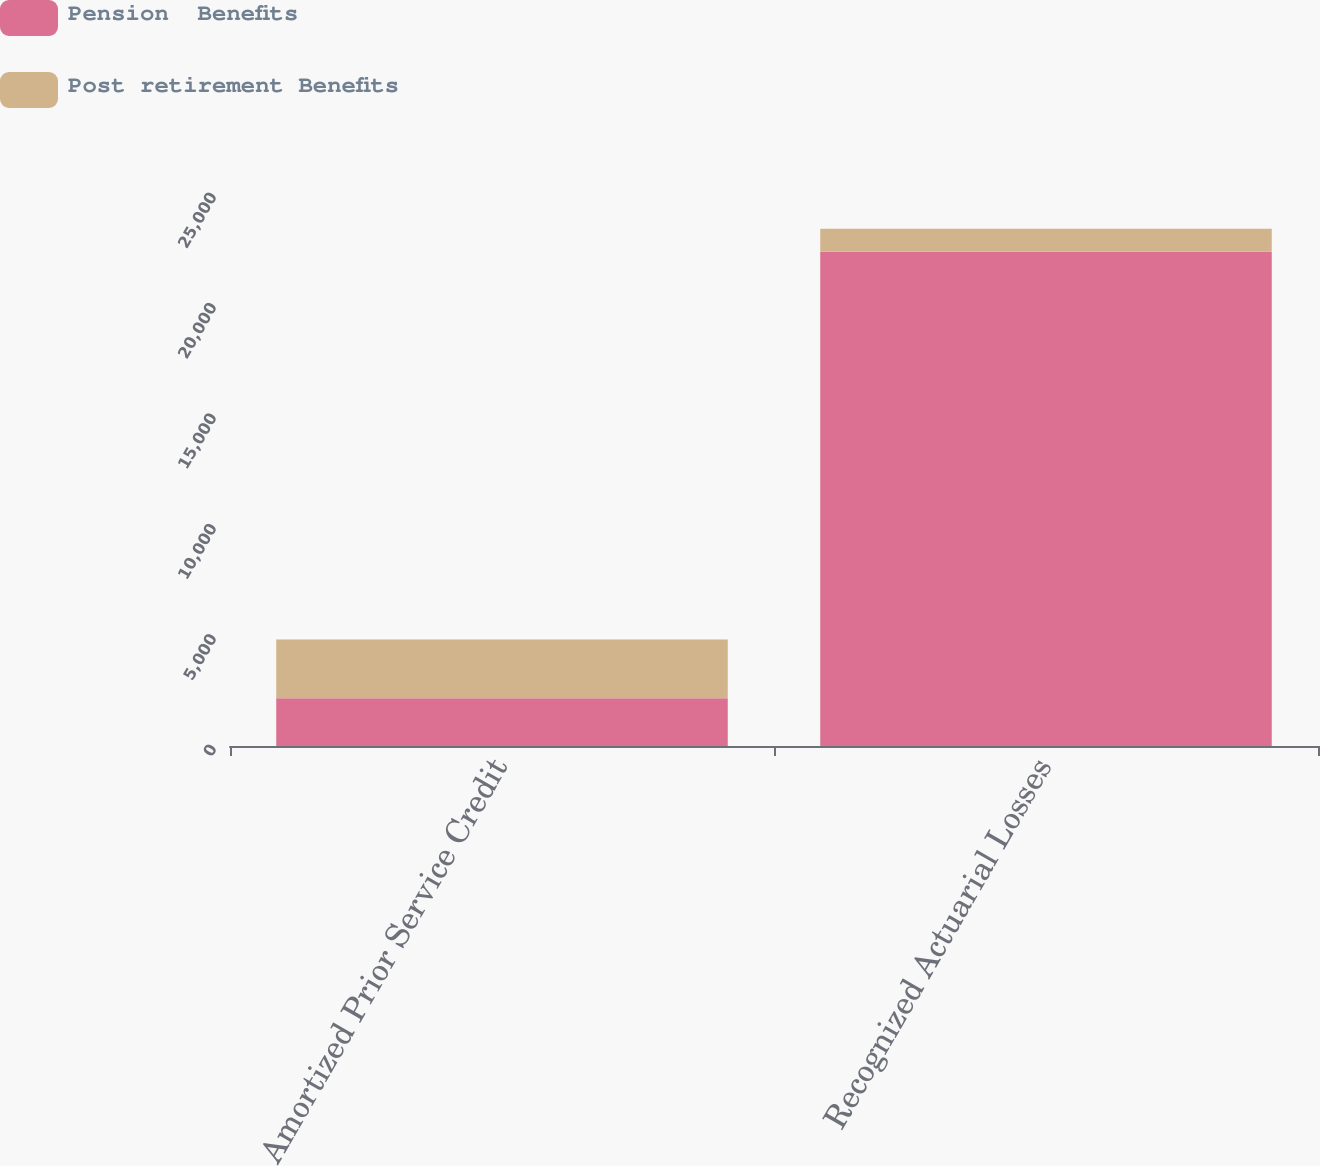Convert chart. <chart><loc_0><loc_0><loc_500><loc_500><stacked_bar_chart><ecel><fcel>Amortized Prior Service Credit<fcel>Recognized Actuarial Losses<nl><fcel>Pension  Benefits<fcel>2168<fcel>22383<nl><fcel>Post retirement Benefits<fcel>2651<fcel>1046<nl></chart> 